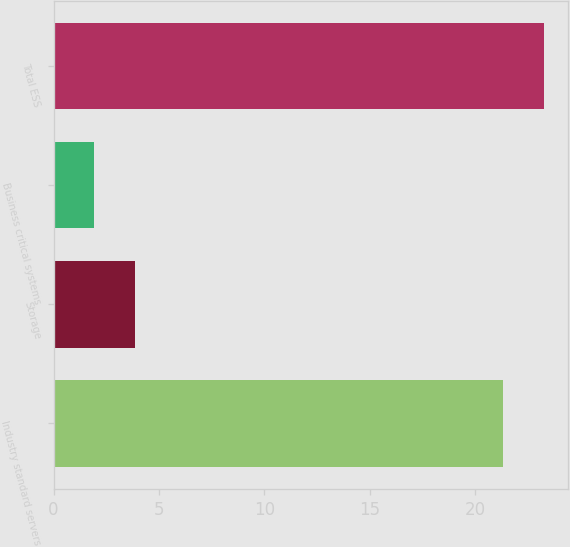<chart> <loc_0><loc_0><loc_500><loc_500><bar_chart><fcel>Industry standard servers<fcel>Storage<fcel>Business critical systems<fcel>Total ESS<nl><fcel>21.3<fcel>3.85<fcel>1.9<fcel>23.25<nl></chart> 